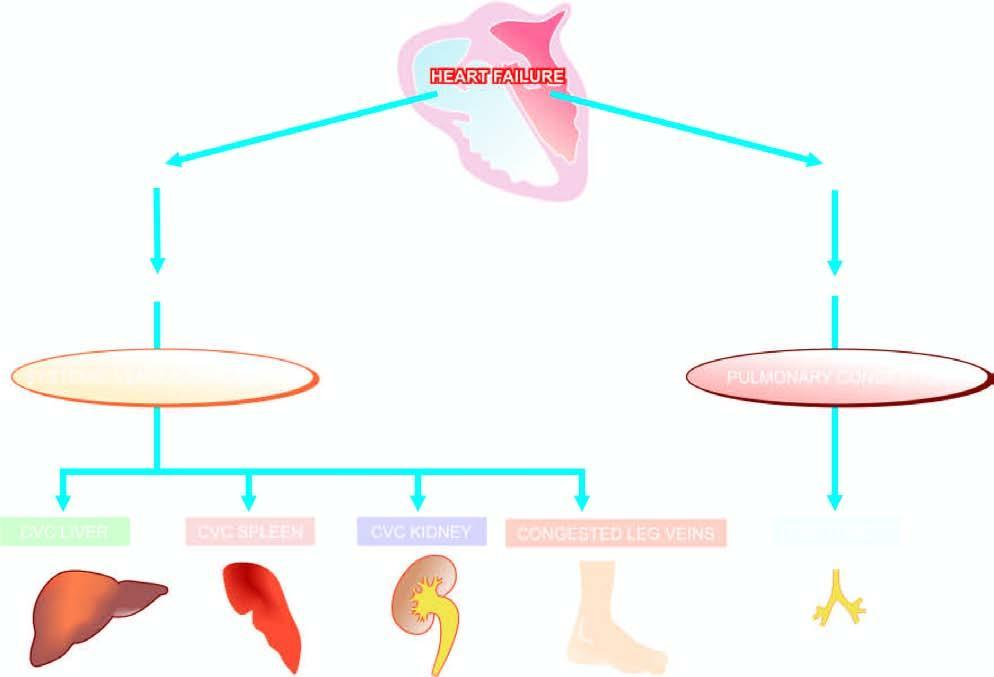re two daughter cells involved in chronic venous congestion of different organs?
Answer the question using a single word or phrase. No 